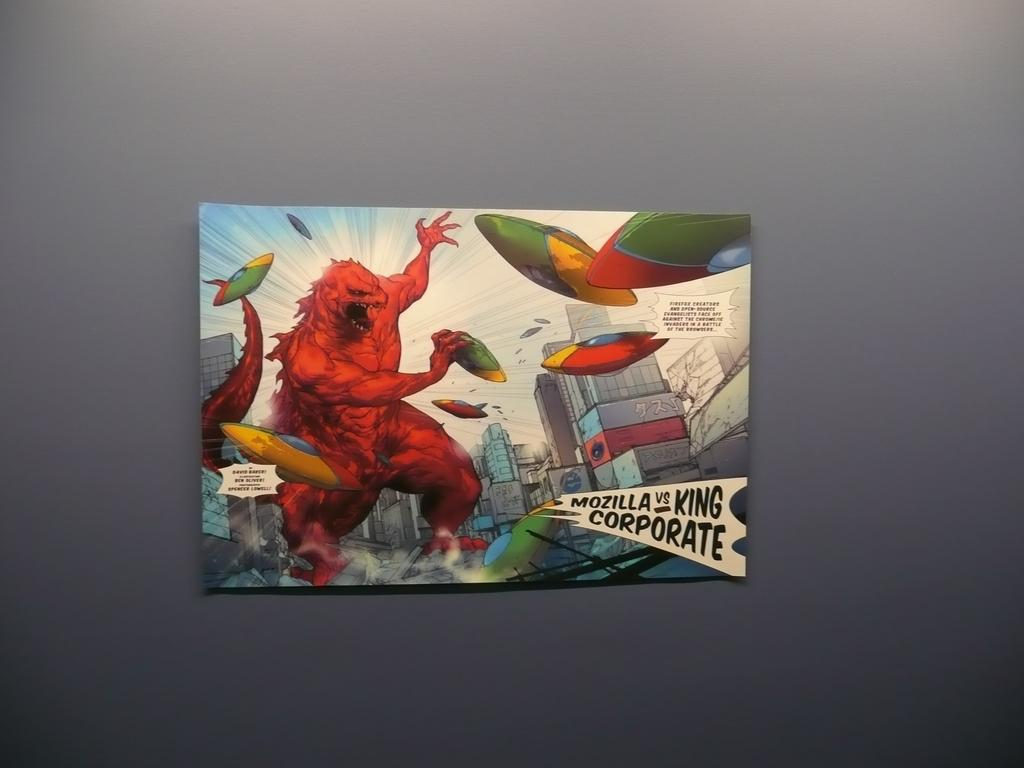<image>
Give a short and clear explanation of the subsequent image. A cartoon drawing shows "Mozilla vs. King Corporate". 